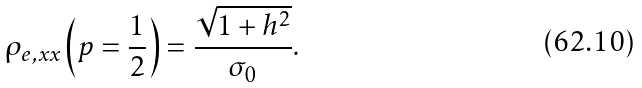<formula> <loc_0><loc_0><loc_500><loc_500>\rho _ { e , x x } \left ( p = \frac { 1 } { 2 } \right ) = \frac { \sqrt { 1 + h ^ { 2 } } } { \sigma _ { 0 } } .</formula> 